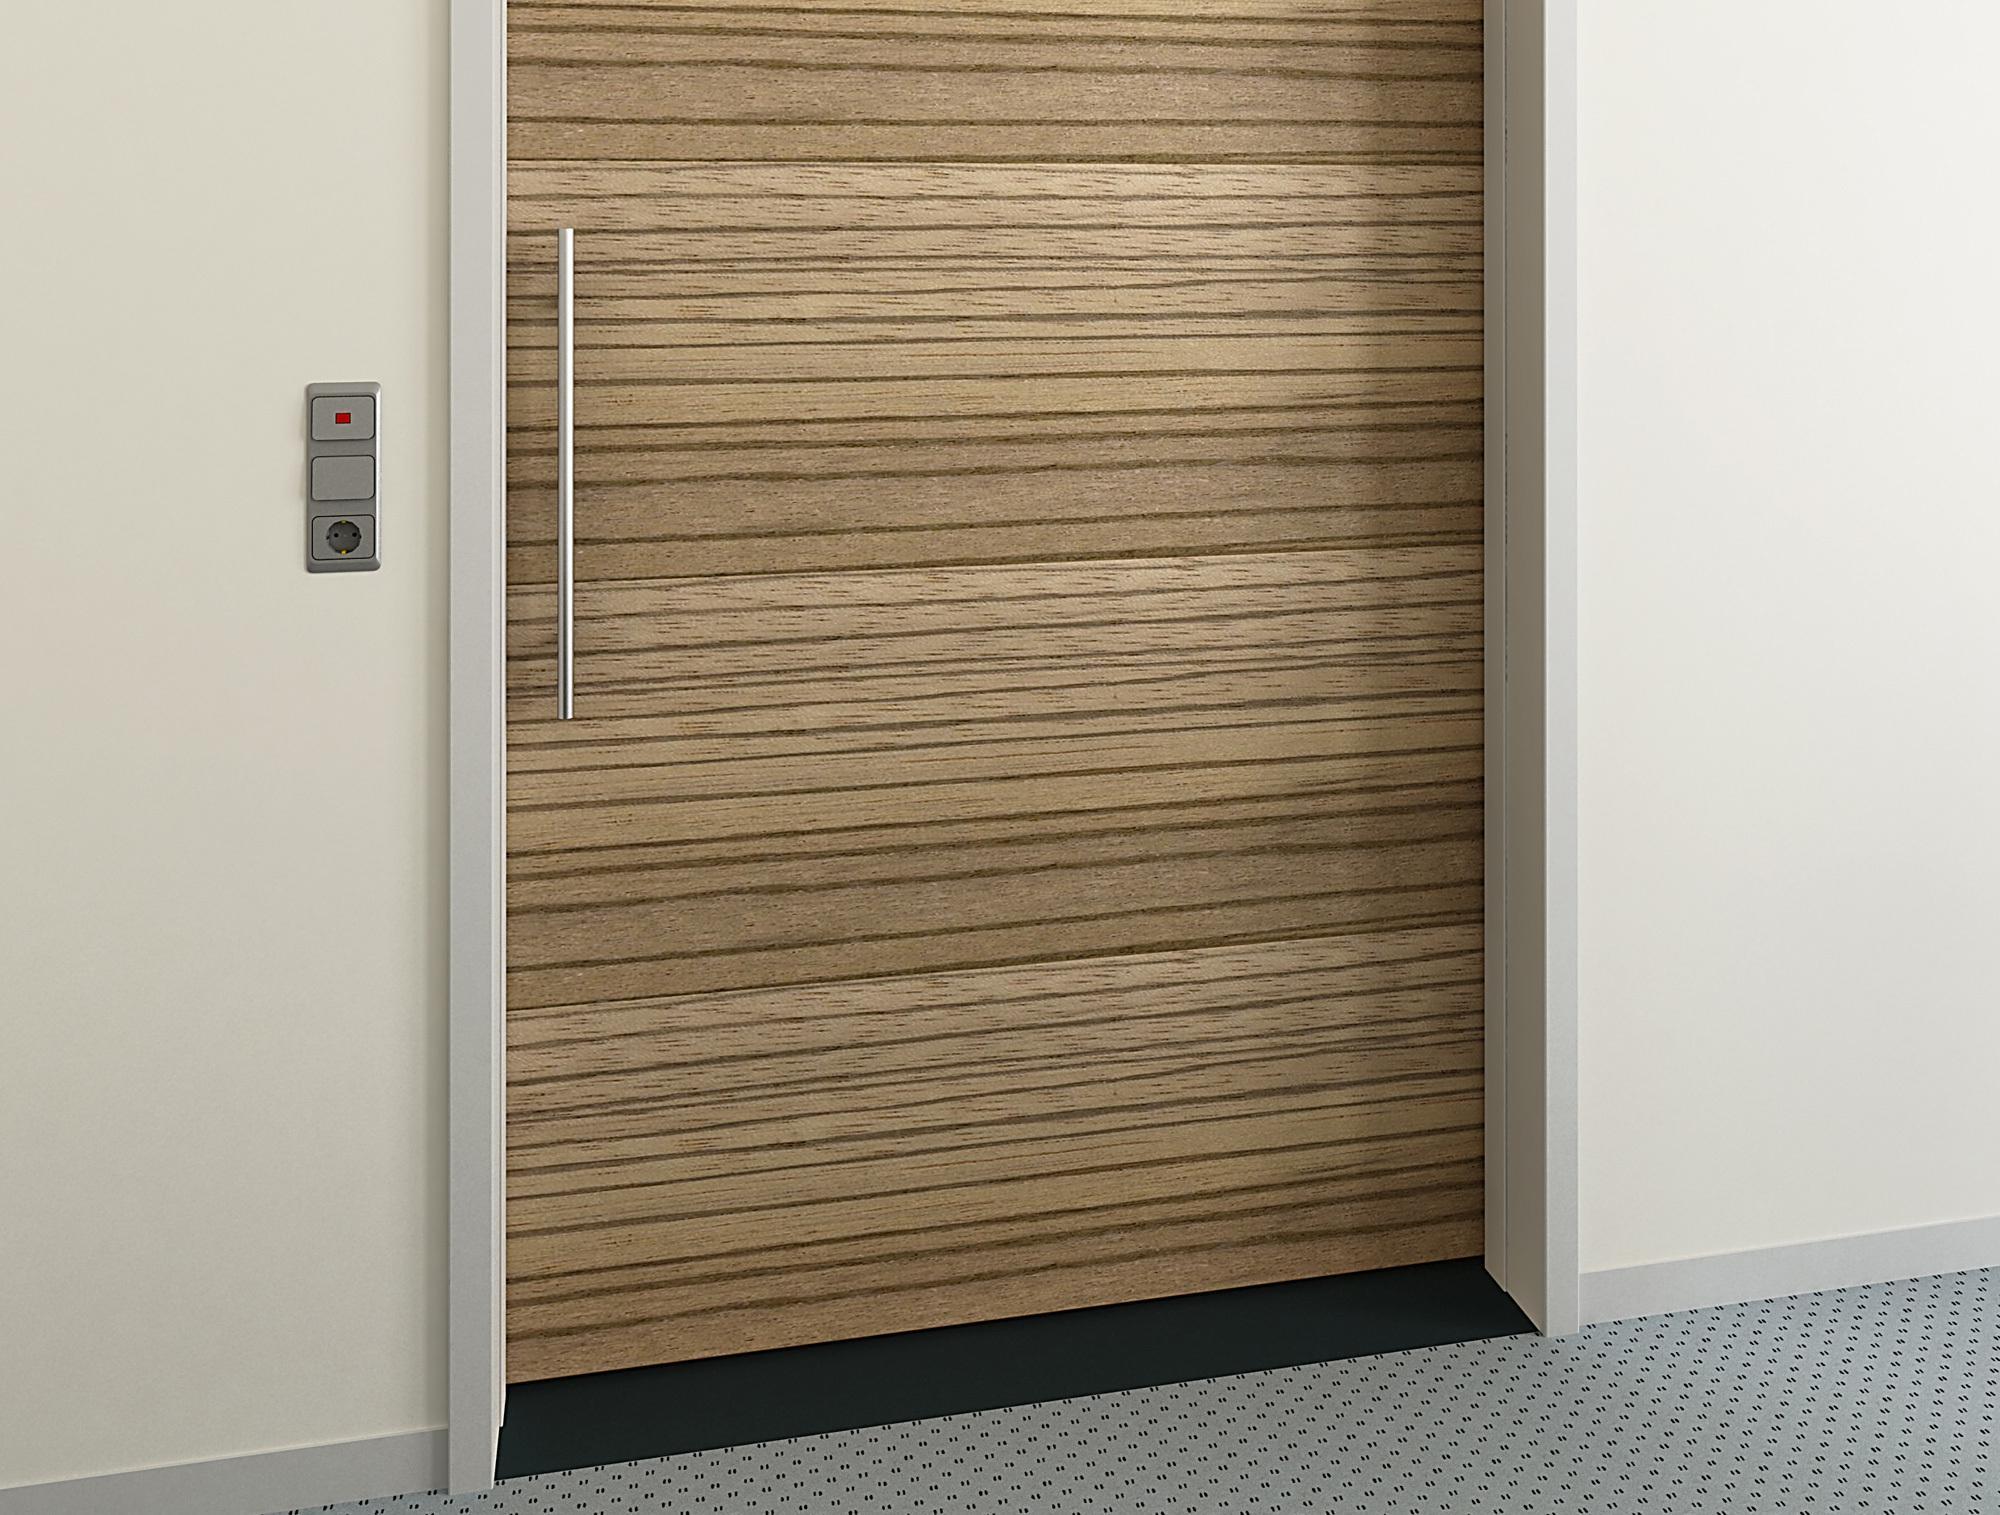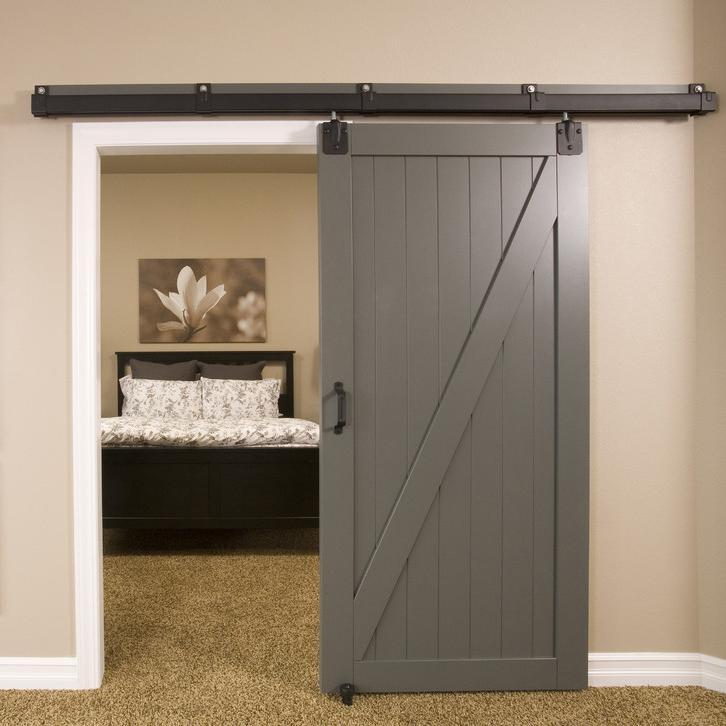The first image is the image on the left, the second image is the image on the right. Examine the images to the left and right. Is the description "One door is glass." accurate? Answer yes or no. No. 